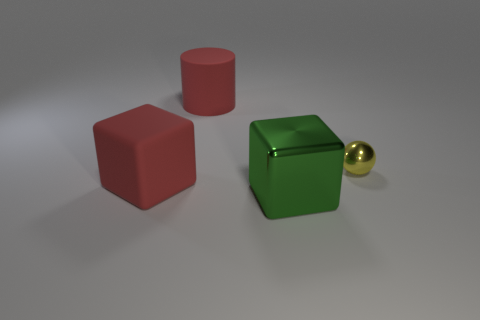Are there any other things that have the same size as the yellow shiny ball?
Make the answer very short. No. The large red thing that is left of the red thing that is right of the large thing that is left of the large cylinder is what shape?
Provide a succinct answer. Cube. What shape is the big rubber thing right of the cube to the left of the green object?
Provide a succinct answer. Cylinder. How big is the red object behind the matte object that is in front of the small yellow thing?
Your answer should be compact. Large. Is the number of green metal things less than the number of small brown matte cubes?
Ensure brevity in your answer.  No. There is a object that is both behind the red cube and on the left side of the tiny yellow shiny sphere; what is its size?
Your answer should be compact. Large. There is a large matte object that is behind the tiny thing; is its color the same as the shiny cube?
Make the answer very short. No. Are there fewer small spheres behind the red matte cylinder than large red cubes?
Your answer should be very brief. Yes. What is the shape of the big object that is the same material as the red block?
Your answer should be compact. Cylinder. Are the tiny sphere and the big red cylinder made of the same material?
Ensure brevity in your answer.  No. 